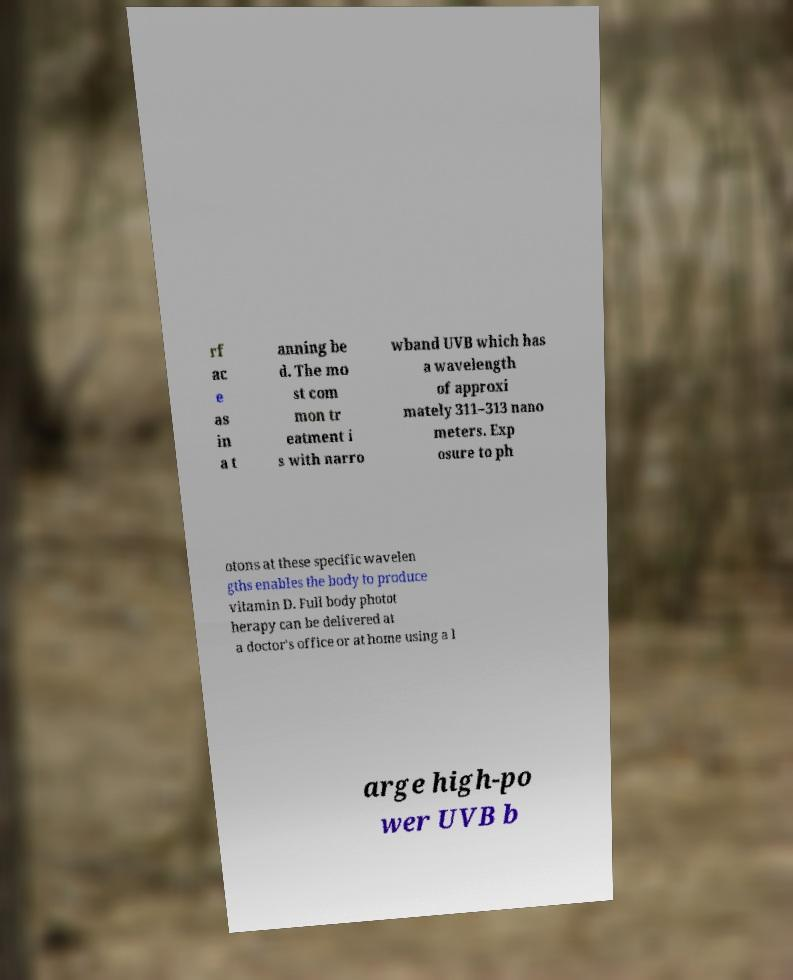What messages or text are displayed in this image? I need them in a readable, typed format. rf ac e as in a t anning be d. The mo st com mon tr eatment i s with narro wband UVB which has a wavelength of approxi mately 311–313 nano meters. Exp osure to ph otons at these specific wavelen gths enables the body to produce vitamin D. Full body photot herapy can be delivered at a doctor's office or at home using a l arge high-po wer UVB b 